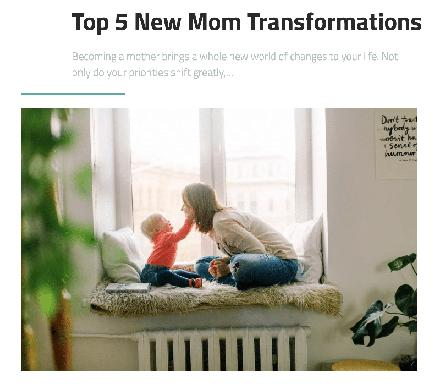What might the text suggest are common feelings or experiences shared by new mothers based on its title and content? Based on the title, 'Top 5 New Mom Transformations,' the text likely explores common emotional and physical experiences such as overwhelming love, fatigue, joy, and the challenge of balancing personal and child needs. These are universal aspects that resonate with the journey of motherhood, reflecting a spectrum of feelings from exhilaration to exhaustion. 